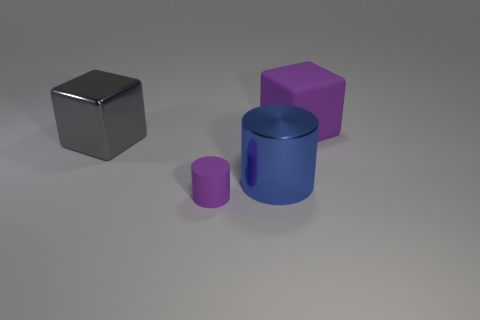There is a object in front of the big cylinder; is its size the same as the cube that is behind the gray block?
Make the answer very short. No. How many other objects are the same size as the matte cube?
Provide a short and direct response. 2. Are there any metallic blocks that are behind the large cube in front of the big cube right of the tiny thing?
Keep it short and to the point. No. Are there any other things of the same color as the metal cylinder?
Offer a very short reply. No. There is a purple rubber thing behind the tiny matte cylinder; what size is it?
Give a very brief answer. Large. What is the size of the purple rubber object behind the purple object that is in front of the matte thing that is right of the purple rubber cylinder?
Your response must be concise. Large. The matte object to the left of the large object that is in front of the gray cube is what color?
Offer a terse response. Purple. There is another blue thing that is the same shape as the small rubber object; what material is it?
Your answer should be compact. Metal. There is a purple matte cylinder; are there any gray objects left of it?
Offer a terse response. Yes. What number of big blue cylinders are there?
Keep it short and to the point. 1. 